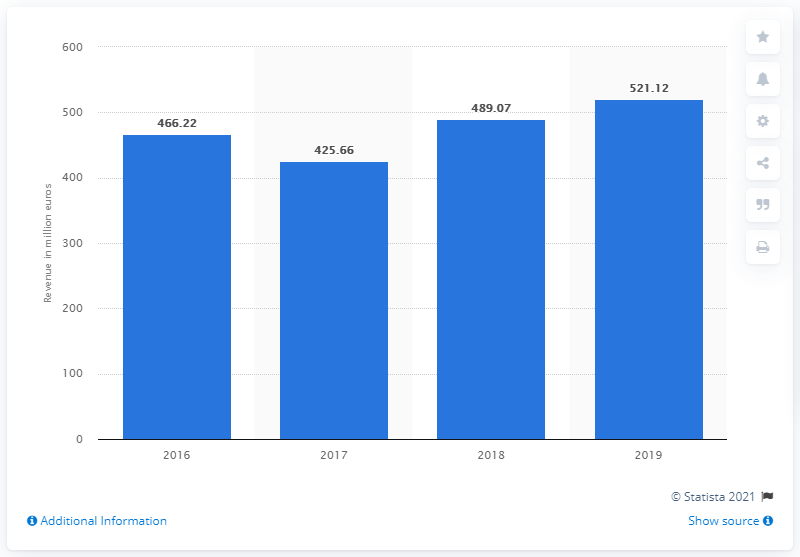Outline some significant characteristics in this image. In 2019, the revenue of ACS Dobfar was 521.12. 